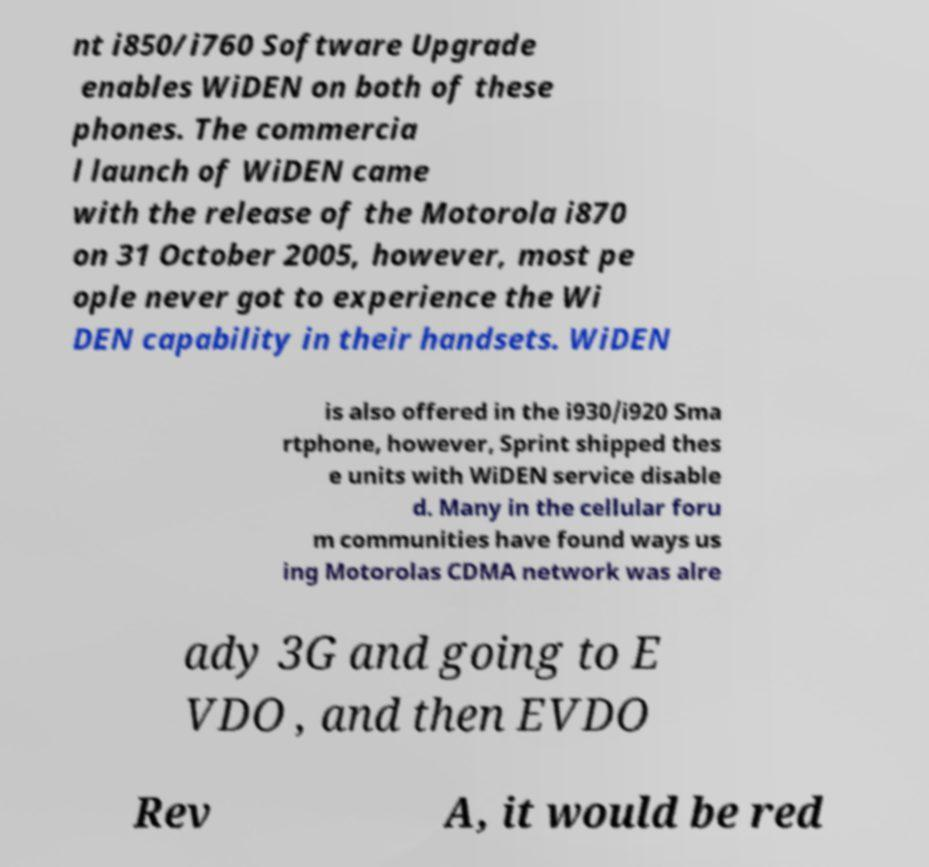Can you read and provide the text displayed in the image?This photo seems to have some interesting text. Can you extract and type it out for me? nt i850/i760 Software Upgrade enables WiDEN on both of these phones. The commercia l launch of WiDEN came with the release of the Motorola i870 on 31 October 2005, however, most pe ople never got to experience the Wi DEN capability in their handsets. WiDEN is also offered in the i930/i920 Sma rtphone, however, Sprint shipped thes e units with WiDEN service disable d. Many in the cellular foru m communities have found ways us ing Motorolas CDMA network was alre ady 3G and going to E VDO , and then EVDO Rev A, it would be red 